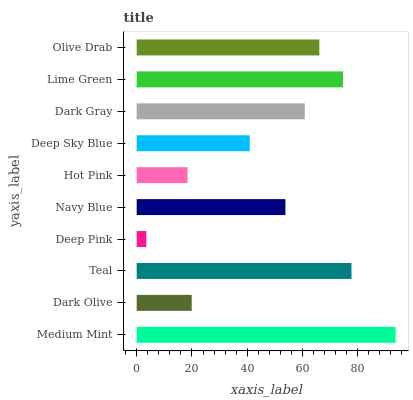Is Deep Pink the minimum?
Answer yes or no. Yes. Is Medium Mint the maximum?
Answer yes or no. Yes. Is Dark Olive the minimum?
Answer yes or no. No. Is Dark Olive the maximum?
Answer yes or no. No. Is Medium Mint greater than Dark Olive?
Answer yes or no. Yes. Is Dark Olive less than Medium Mint?
Answer yes or no. Yes. Is Dark Olive greater than Medium Mint?
Answer yes or no. No. Is Medium Mint less than Dark Olive?
Answer yes or no. No. Is Dark Gray the high median?
Answer yes or no. Yes. Is Navy Blue the low median?
Answer yes or no. Yes. Is Dark Olive the high median?
Answer yes or no. No. Is Deep Sky Blue the low median?
Answer yes or no. No. 